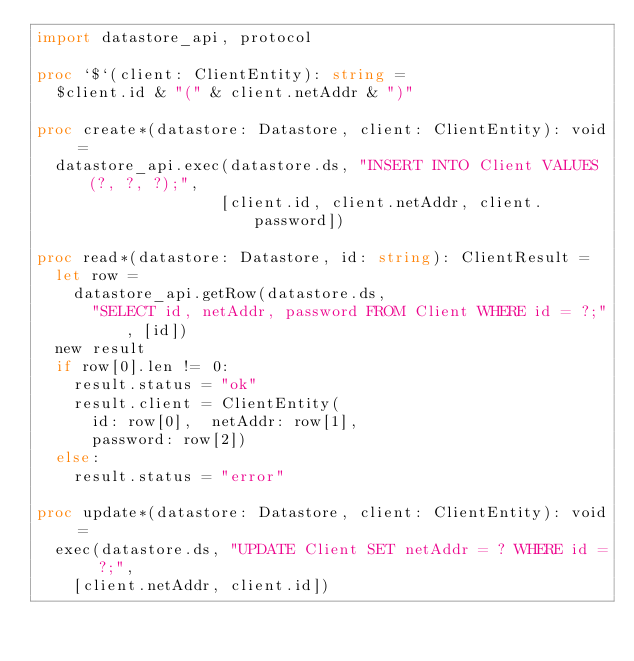<code> <loc_0><loc_0><loc_500><loc_500><_Nim_>import datastore_api, protocol

proc `$`(client: ClientEntity): string =
  $client.id & "(" & client.netAddr & ")"

proc create*(datastore: Datastore, client: ClientEntity): void =
  datastore_api.exec(datastore.ds, "INSERT INTO Client VALUES (?, ?, ?);",
                    [client.id, client.netAddr, client.password])

proc read*(datastore: Datastore, id: string): ClientResult =
  let row =
    datastore_api.getRow(datastore.ds,
      "SELECT id, netAddr, password FROM Client WHERE id = ?;", [id])
  new result
  if row[0].len != 0:
    result.status = "ok"
    result.client = ClientEntity(
      id: row[0],  netAddr: row[1],
      password: row[2])
  else:
    result.status = "error"

proc update*(datastore: Datastore, client: ClientEntity): void =
  exec(datastore.ds, "UPDATE Client SET netAddr = ? WHERE id = ?;",
    [client.netAddr, client.id])
  

</code> 